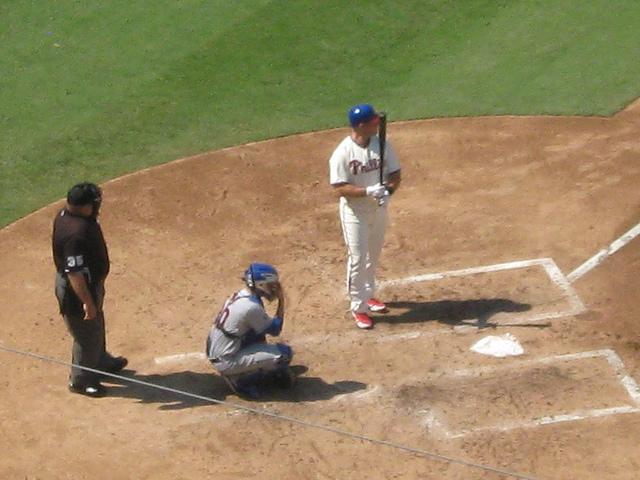Is the umpire standing straight up?
Keep it brief. Yes. Is the guy in white the winner of the game?
Concise answer only. No. What position does the guy in the middle play?
Write a very short answer. Catcher. What sport is this?
Quick response, please. Baseball. Are the players waiting for the next pitch?
Write a very short answer. Yes. 